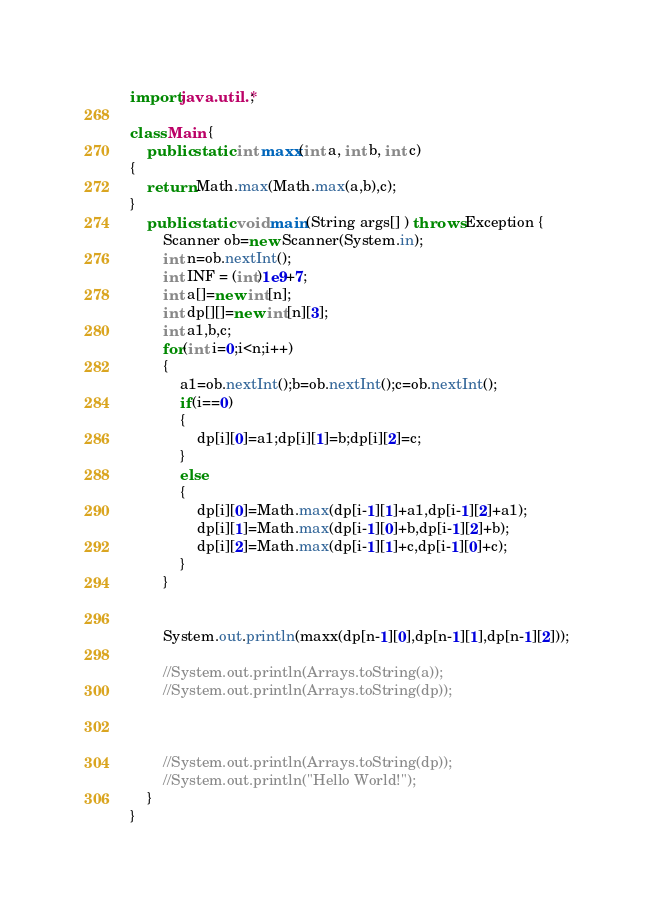<code> <loc_0><loc_0><loc_500><loc_500><_Java_>import java.util.*;

class Main {
    public static int maxx(int a, int b, int c)
{
    return Math.max(Math.max(a,b),c);
}
    public static void main(String args[] ) throws Exception {
        Scanner ob=new Scanner(System.in);
        int n=ob.nextInt();
        int INF = (int)1e9+7;
        int a[]=new int[n];
        int dp[][]=new int[n][3];
        int a1,b,c;
        for(int i=0;i<n;i++)
        {
            a1=ob.nextInt();b=ob.nextInt();c=ob.nextInt();
            if(i==0)
            {
                dp[i][0]=a1;dp[i][1]=b;dp[i][2]=c;
            }
            else
            {
                dp[i][0]=Math.max(dp[i-1][1]+a1,dp[i-1][2]+a1);
                dp[i][1]=Math.max(dp[i-1][0]+b,dp[i-1][2]+b);
                dp[i][2]=Math.max(dp[i-1][1]+c,dp[i-1][0]+c);
            }
        }
        
       
        System.out.println(maxx(dp[n-1][0],dp[n-1][1],dp[n-1][2]));
        
        //System.out.println(Arrays.toString(a));
        //System.out.println(Arrays.toString(dp));
        
        
        
        //System.out.println(Arrays.toString(dp));
        //System.out.println("Hello World!");
    }
}
</code> 